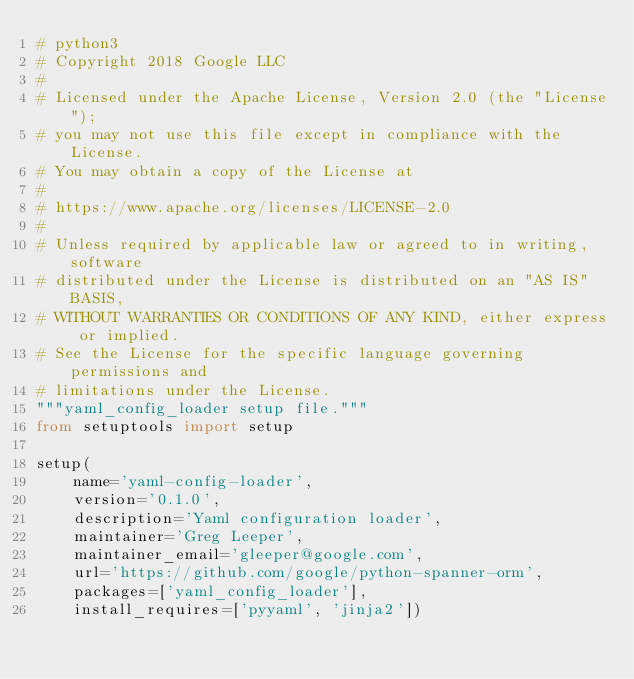<code> <loc_0><loc_0><loc_500><loc_500><_Python_># python3
# Copyright 2018 Google LLC
#
# Licensed under the Apache License, Version 2.0 (the "License");
# you may not use this file except in compliance with the License.
# You may obtain a copy of the License at
#
# https://www.apache.org/licenses/LICENSE-2.0
#
# Unless required by applicable law or agreed to in writing, software
# distributed under the License is distributed on an "AS IS" BASIS,
# WITHOUT WARRANTIES OR CONDITIONS OF ANY KIND, either express or implied.
# See the License for the specific language governing permissions and
# limitations under the License.
"""yaml_config_loader setup file."""
from setuptools import setup

setup(
    name='yaml-config-loader',
    version='0.1.0',
    description='Yaml configuration loader',
    maintainer='Greg Leeper',
    maintainer_email='gleeper@google.com',
    url='https://github.com/google/python-spanner-orm',
    packages=['yaml_config_loader'],
    install_requires=['pyyaml', 'jinja2'])
</code> 